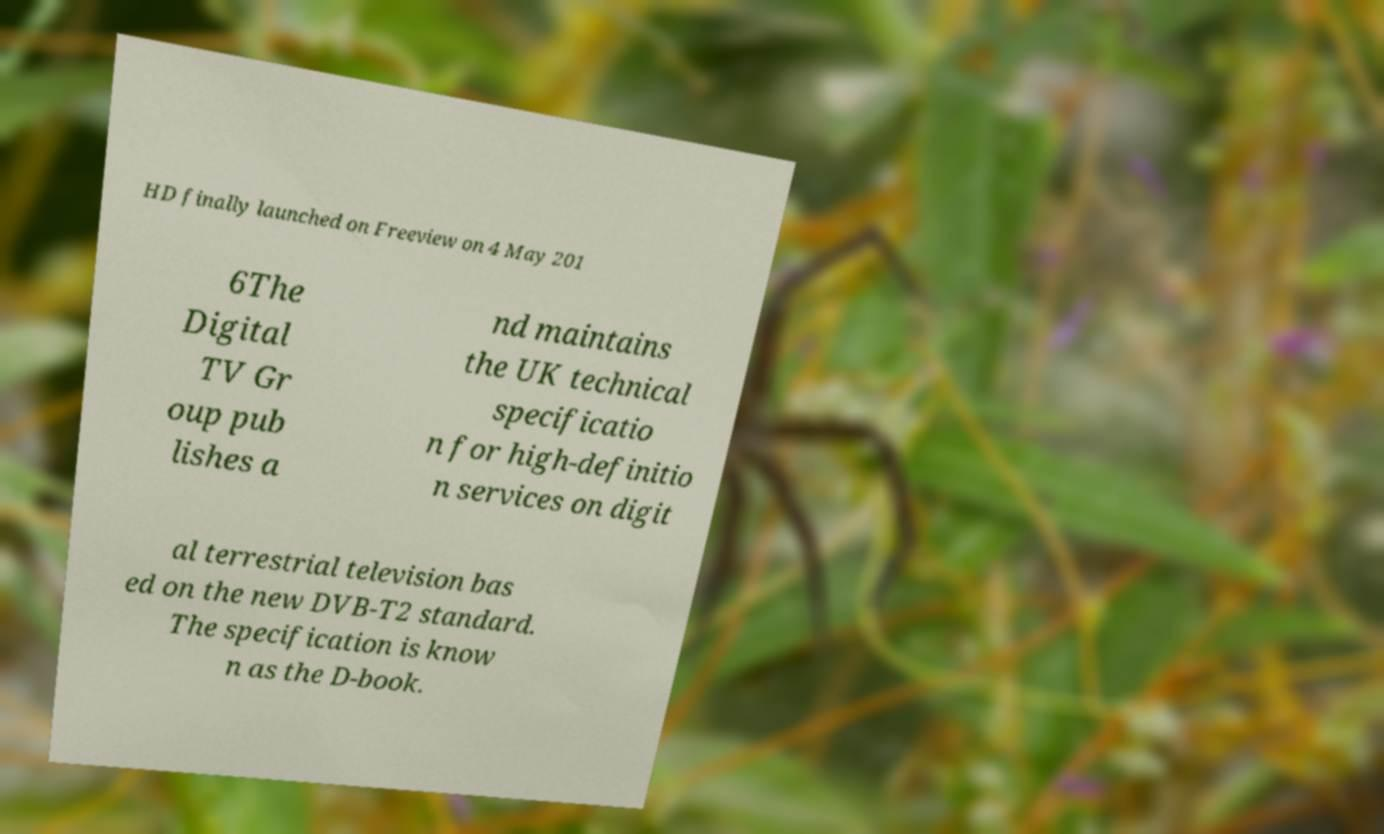Please identify and transcribe the text found in this image. HD finally launched on Freeview on 4 May 201 6The Digital TV Gr oup pub lishes a nd maintains the UK technical specificatio n for high-definitio n services on digit al terrestrial television bas ed on the new DVB-T2 standard. The specification is know n as the D-book. 